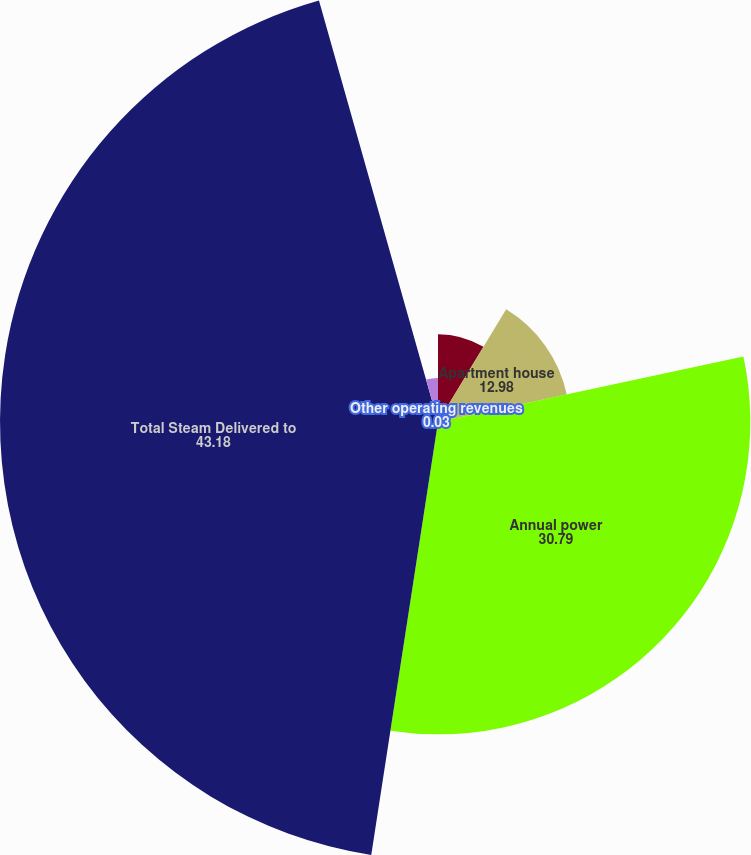Convert chart to OTSL. <chart><loc_0><loc_0><loc_500><loc_500><pie_chart><fcel>General<fcel>Apartment house<fcel>Annual power<fcel>Total Steam Delivered to<fcel>Other operating revenues<fcel>Average Revenue per MMlb Sold<nl><fcel>8.66%<fcel>12.98%<fcel>30.79%<fcel>43.18%<fcel>0.03%<fcel>4.35%<nl></chart> 